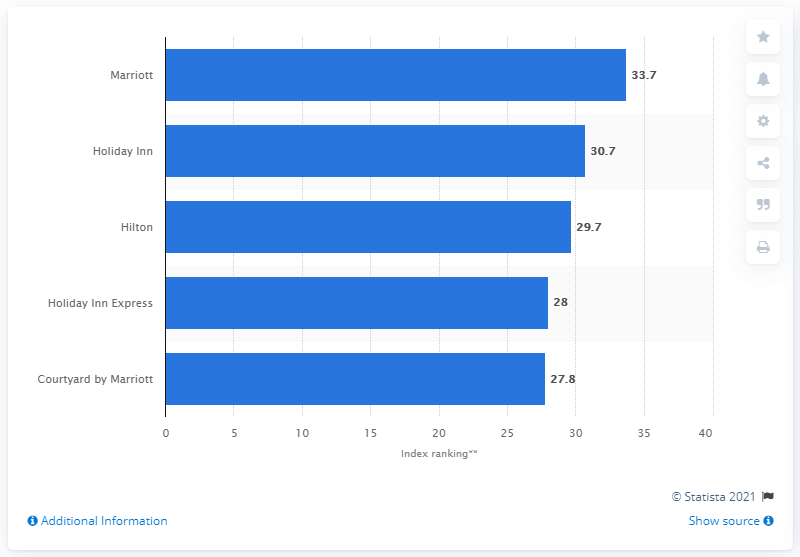Give some essential details in this illustration. Marriott's score in 2018 was 33.7. 